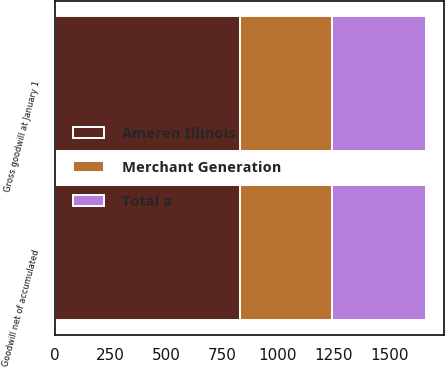<chart> <loc_0><loc_0><loc_500><loc_500><stacked_bar_chart><ecel><fcel>Gross goodwill at January 1<fcel>Goodwill net of accumulated<nl><fcel>Merchant Generation<fcel>411<fcel>411<nl><fcel>Total a<fcel>420<fcel>420<nl><fcel>Ameren Illinois<fcel>831<fcel>831<nl></chart> 